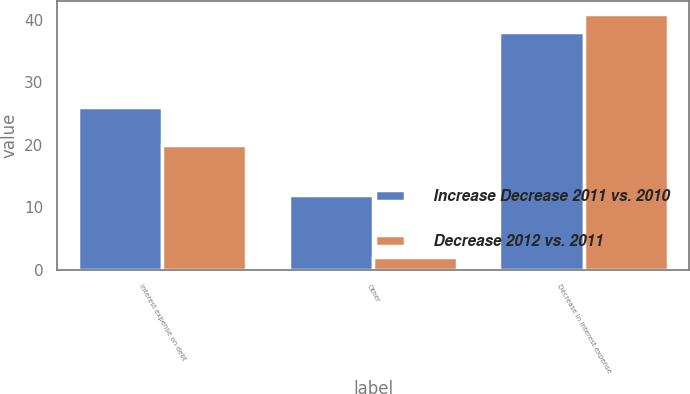Convert chart to OTSL. <chart><loc_0><loc_0><loc_500><loc_500><stacked_bar_chart><ecel><fcel>Interest expense on debt<fcel>Other<fcel>Decrease in interest expense<nl><fcel>Increase Decrease 2011 vs. 2010<fcel>26<fcel>12<fcel>38<nl><fcel>Decrease 2012 vs. 2011<fcel>20<fcel>2<fcel>41<nl></chart> 